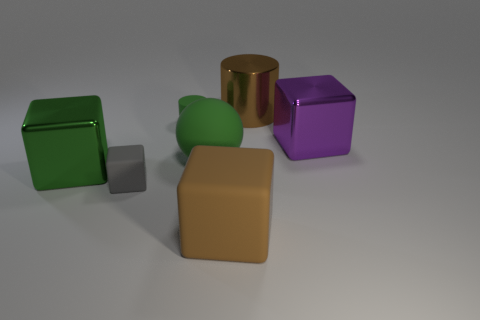Subtract all cylinders. How many objects are left? 5 Subtract all large cubes. How many cubes are left? 1 Subtract 3 blocks. How many blocks are left? 1 Subtract all brown cubes. Subtract all cyan cylinders. How many cubes are left? 3 Subtract all purple cylinders. How many cyan balls are left? 0 Subtract all metal spheres. Subtract all large green balls. How many objects are left? 6 Add 7 tiny matte cylinders. How many tiny matte cylinders are left? 8 Add 4 rubber spheres. How many rubber spheres exist? 5 Add 2 big green metal cubes. How many objects exist? 9 Subtract all green cylinders. How many cylinders are left? 1 